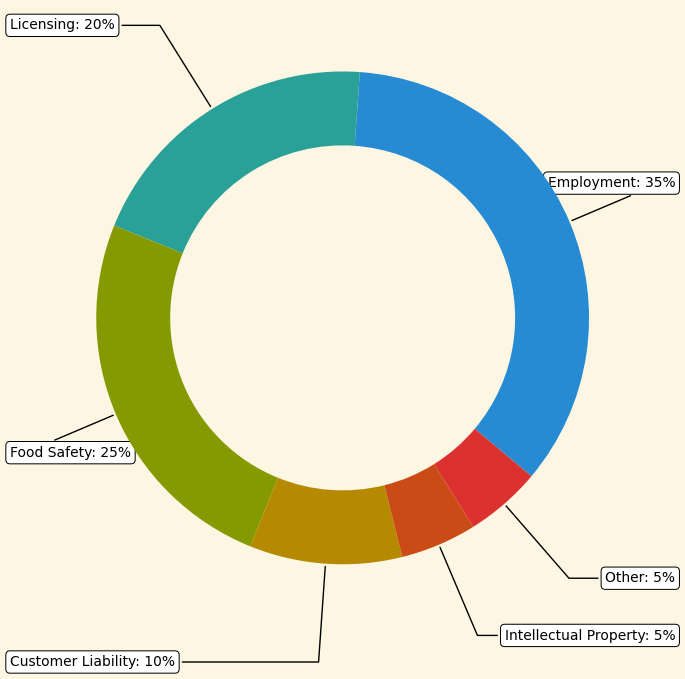What's the largest proportion of legal claims attributed to? By looking at the chart, the Employment section takes up the largest segment, labeled 35%.
Answer: Employment Which issue type has a higher proportion, Licensing or Food Safety? Comparing the chart segments labeled Licensing (20%) and Food Safety (25%), Food Safety is higher.
Answer: Food Safety What is the combined proportion of legal claims for Licensing and Customer Liability? Adding the proportions: Licensing is 20% and Customer Liability is 10%. 20% + 10% = 30%.
Answer: 30% Are there more legal claims related to Employment or the sum of Licensing and Food Safety? Employment is 35%. The sum of Licensing (20%) and Food Safety (25%) is 45%. Since 45% > 35%, the sum of Licensing and Food Safety is higher.
Answer: The sum of Licensing and Food Safety What proportion of legal claims does the "Other" issue type account for, and how does it compare to Intellectual Property? Both the "Other" and Intellectual Property segments are labeled 5%, indicating they are equal.
Answer: 5% and equal How much more significant is the proportion of Customer Liability compared to Intellectual Property? Customer Liability is 10%, and Intellectual Property is 5%. The difference is 10% - 5% = 5%.
Answer: 5% What's the total proportion of legal claims covered by the three largest issue types? The three largest issue types are Employment (35%), Food Safety (25%), and Licensing (20%). Adding their proportions: 35% + 25% + 20% = 80%.
Answer: 80% Which issue types have the smallest and largest sections in the chart? The smallest sections, both at 5%, are "Other" and Intellectual Property. The largest is Employment at 35%.
Answer: Smallest: Other and Intellectual Property; Largest: Employment How does the Employment segment visually compare with the Customer Liability segment on the chart? The Employment segment is significantly larger than the Customer Liability segment. Employment covers 35%, while Customer Liability covers only 10%. Visually, Employment is over three times larger.
Answer: Employment is significantly larger What is the difference in proportion between the largest and the smallest categories? The largest category is Employment at 35%, and the smallest categories are Other and Intellectual Property at 5% each. The difference is 35% - 5% = 30%.
Answer: 30% 